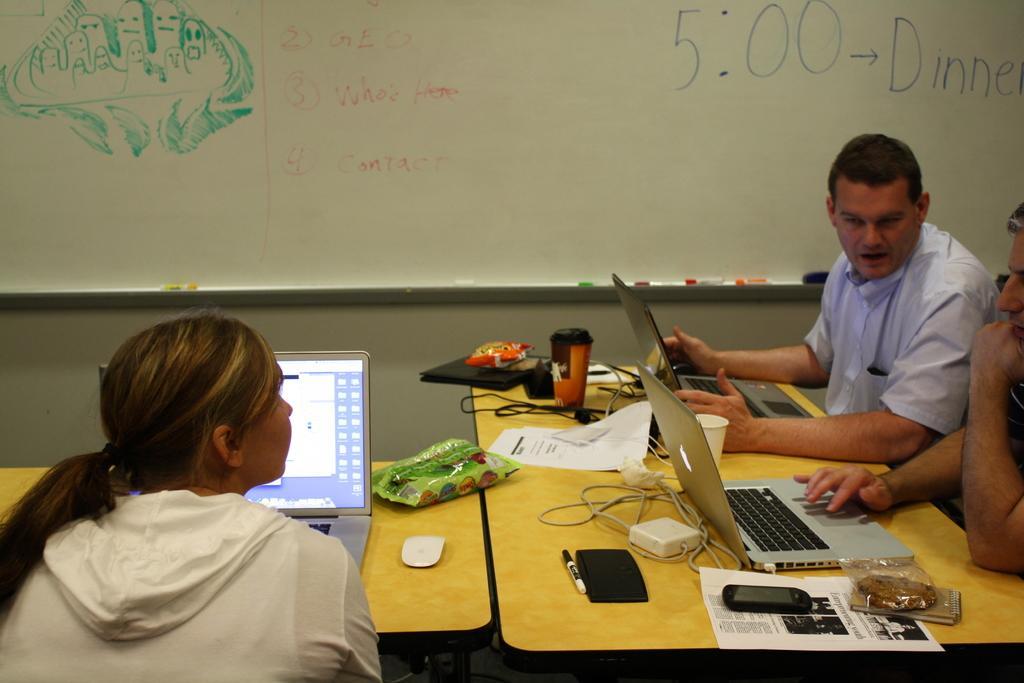Please provide a concise description of this image. In this image there are people sitting on the chairs. In front of them there are tables. On top of it there are laptops and a few other objects. In the background of the image there is a board with some text and pictures on it on the wall. 